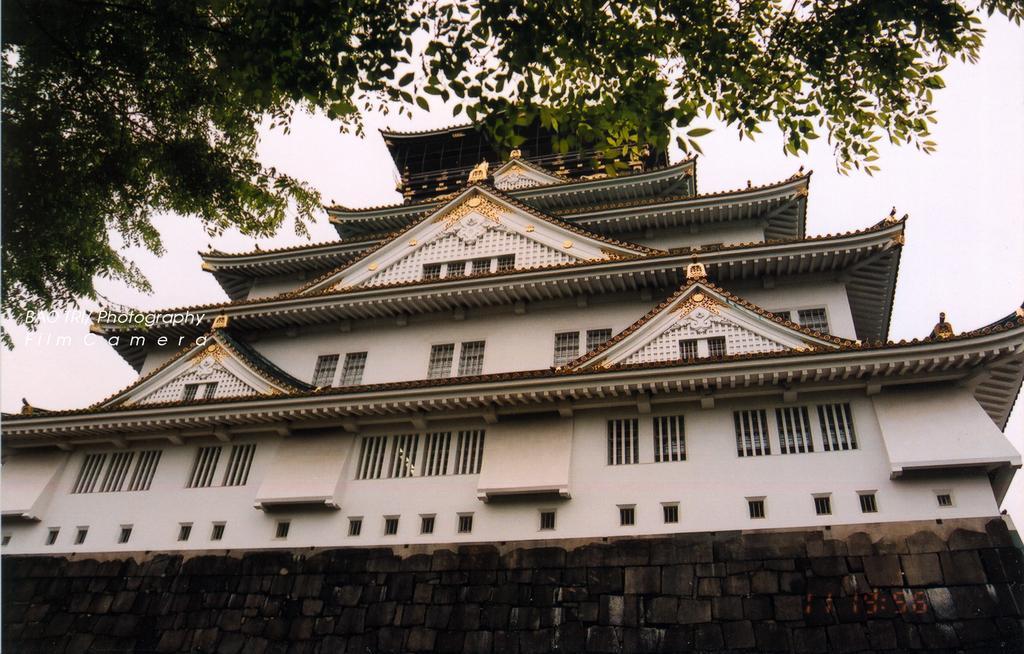How would you summarize this image in a sentence or two? In the center of the image we can see a building, windows, wall. On the left side of the image we can see some text. At the top of the image we can see a tree and sky. 